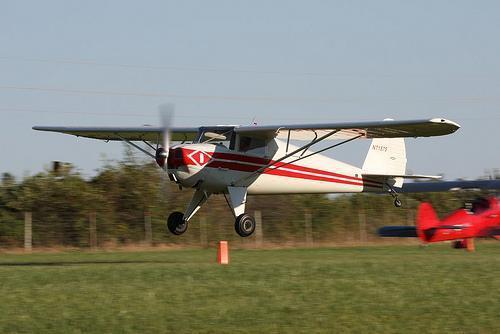How many planes are in the air?
Give a very brief answer. 1. How many red-striped planes are there?
Give a very brief answer. 1. 